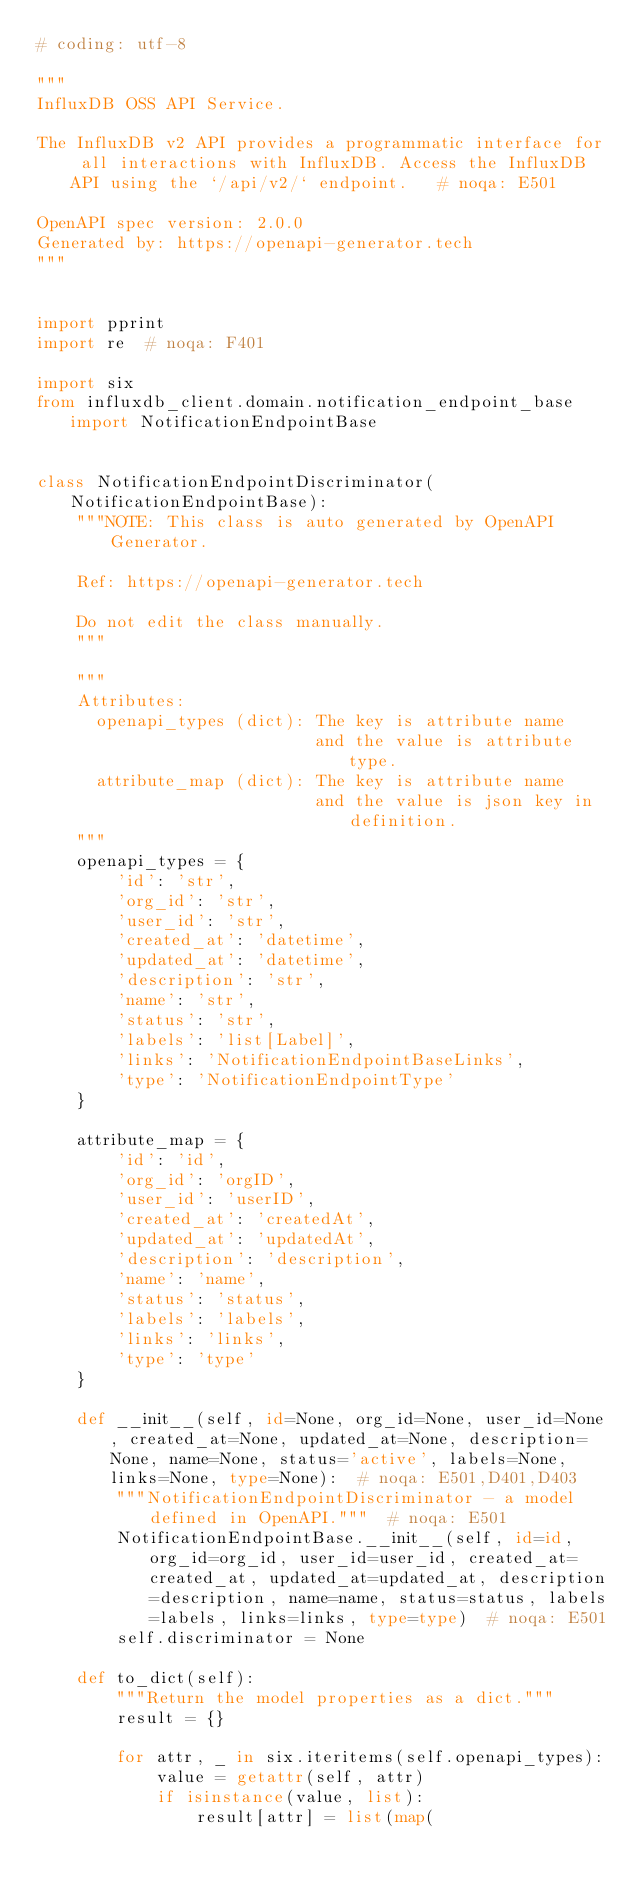<code> <loc_0><loc_0><loc_500><loc_500><_Python_># coding: utf-8

"""
InfluxDB OSS API Service.

The InfluxDB v2 API provides a programmatic interface for all interactions with InfluxDB. Access the InfluxDB API using the `/api/v2/` endpoint.   # noqa: E501

OpenAPI spec version: 2.0.0
Generated by: https://openapi-generator.tech
"""


import pprint
import re  # noqa: F401

import six
from influxdb_client.domain.notification_endpoint_base import NotificationEndpointBase


class NotificationEndpointDiscriminator(NotificationEndpointBase):
    """NOTE: This class is auto generated by OpenAPI Generator.

    Ref: https://openapi-generator.tech

    Do not edit the class manually.
    """

    """
    Attributes:
      openapi_types (dict): The key is attribute name
                            and the value is attribute type.
      attribute_map (dict): The key is attribute name
                            and the value is json key in definition.
    """
    openapi_types = {
        'id': 'str',
        'org_id': 'str',
        'user_id': 'str',
        'created_at': 'datetime',
        'updated_at': 'datetime',
        'description': 'str',
        'name': 'str',
        'status': 'str',
        'labels': 'list[Label]',
        'links': 'NotificationEndpointBaseLinks',
        'type': 'NotificationEndpointType'
    }

    attribute_map = {
        'id': 'id',
        'org_id': 'orgID',
        'user_id': 'userID',
        'created_at': 'createdAt',
        'updated_at': 'updatedAt',
        'description': 'description',
        'name': 'name',
        'status': 'status',
        'labels': 'labels',
        'links': 'links',
        'type': 'type'
    }

    def __init__(self, id=None, org_id=None, user_id=None, created_at=None, updated_at=None, description=None, name=None, status='active', labels=None, links=None, type=None):  # noqa: E501,D401,D403
        """NotificationEndpointDiscriminator - a model defined in OpenAPI."""  # noqa: E501
        NotificationEndpointBase.__init__(self, id=id, org_id=org_id, user_id=user_id, created_at=created_at, updated_at=updated_at, description=description, name=name, status=status, labels=labels, links=links, type=type)  # noqa: E501
        self.discriminator = None

    def to_dict(self):
        """Return the model properties as a dict."""
        result = {}

        for attr, _ in six.iteritems(self.openapi_types):
            value = getattr(self, attr)
            if isinstance(value, list):
                result[attr] = list(map(</code> 